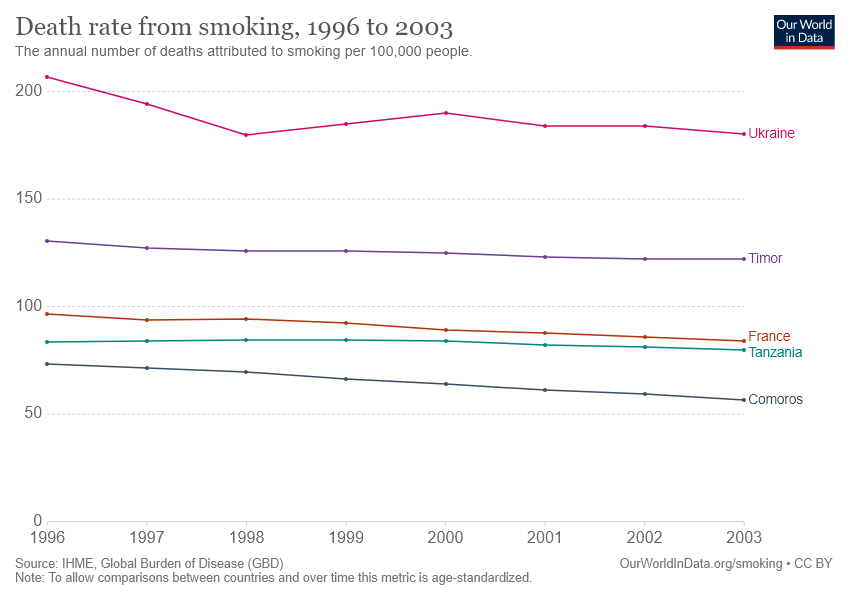Draw attention to some important aspects in this diagram. The bar between the range of 100 to 200 that shows the Death rate from smoking is Timor. The color of the bar that shows the highest death rate from smoking in the year 1996 is pink. 